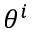Convert formula to latex. <formula><loc_0><loc_0><loc_500><loc_500>\theta ^ { i }</formula> 